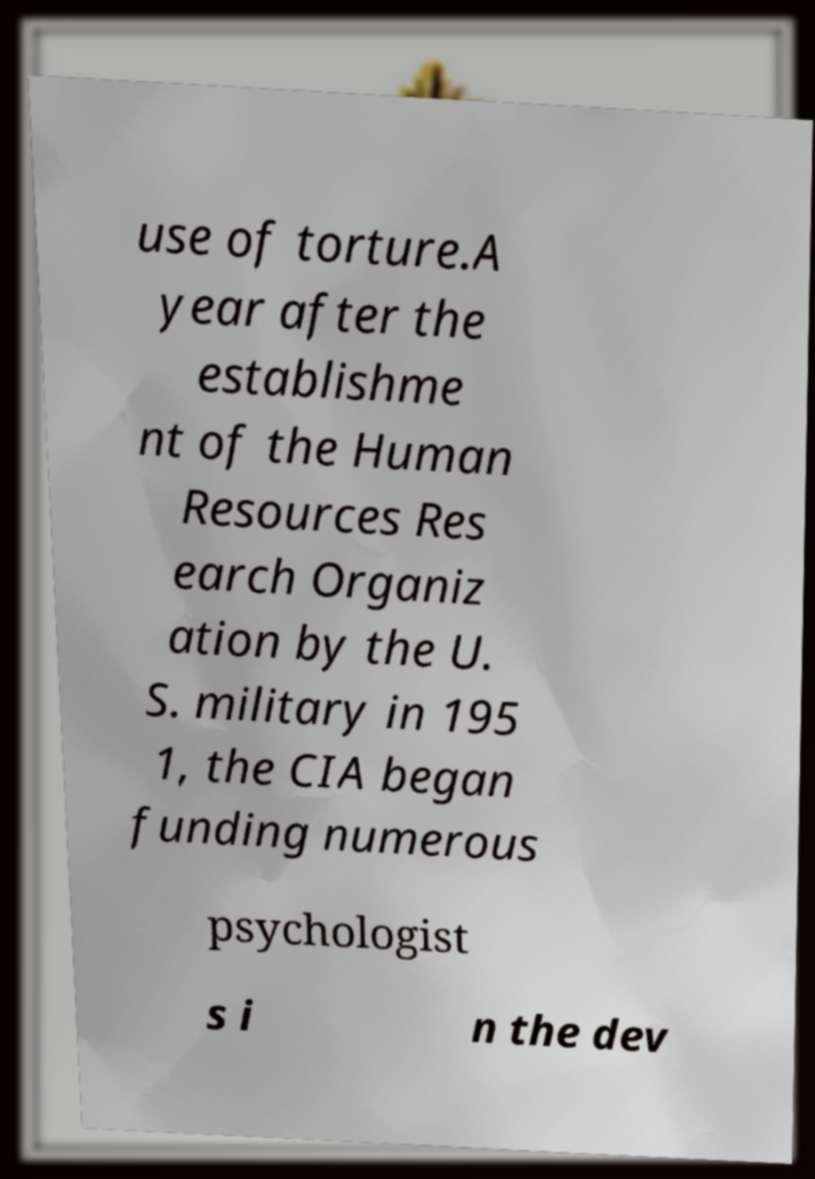Could you assist in decoding the text presented in this image and type it out clearly? use of torture.A year after the establishme nt of the Human Resources Res earch Organiz ation by the U. S. military in 195 1, the CIA began funding numerous psychologist s i n the dev 